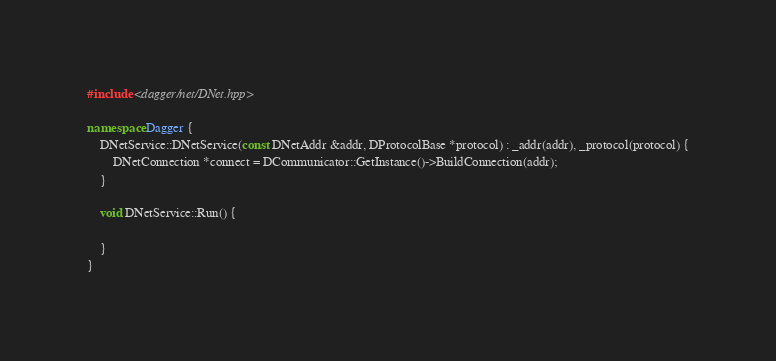Convert code to text. <code><loc_0><loc_0><loc_500><loc_500><_C++_>
#include <dagger/net/DNet.hpp>

namespace Dagger {
    DNetService::DNetService(const DNetAddr &addr, DProtocolBase *protocol) : _addr(addr), _protocol(protocol) {
        DNetConnection *connect = DCommunicator::GetInstance()->BuildConnection(addr);
    }

    void DNetService::Run() {

    }
}
</code> 